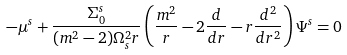<formula> <loc_0><loc_0><loc_500><loc_500>- \mu ^ { s } + \frac { \Sigma _ { 0 } ^ { s } } { ( m ^ { 2 } - 2 ) \Omega _ { s } ^ { 2 } r } \left ( \frac { m ^ { 2 } } { r } - 2 \frac { d } { d r } - r \frac { d ^ { 2 } } { d r ^ { 2 } } \right ) \Psi ^ { s } = 0</formula> 